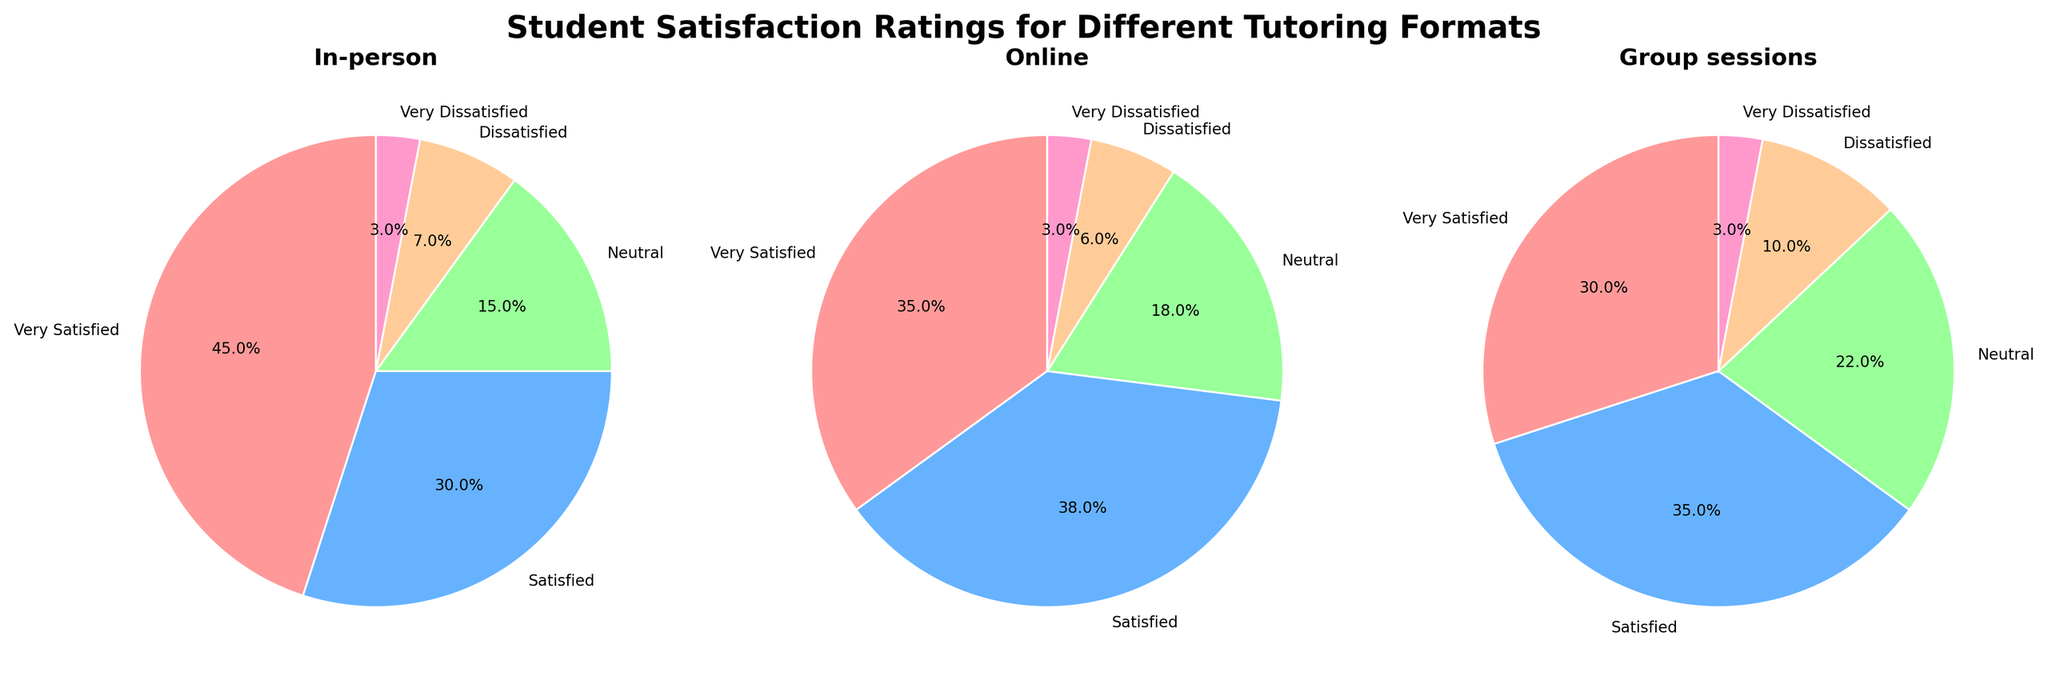What is the title of the figure? The title can be found at the top of the figure and it usually describes what the figure is about.
Answer: Student Satisfaction Ratings for Different Tutoring Formats Which tutoring format has the highest percentage of 'Very Satisfied' students? By looking at the largest segment labeled 'Very Satisfied' and comparing the percentages among the three pie charts.
Answer: In-person What is the combined percentage of 'Dissatisfied' and 'Very Dissatisfied' students in the Online format? Add the percentages of the 'Dissatisfied' and 'Very Dissatisfied' sections in the Online pie chart (6% and 3%).
Answer: 9% How does the percentage of 'Neutral' students in Group sessions compare to that in the In-person format? Compare the 'Neutral' section in both Group sessions and In-person pie charts (22% vs 15%).
Answer: Group sessions is higher by 7% Which tutoring format has the smallest proportion of 'Satisfied' students? Compare the 'Satisfied' sections across all three pie charts (30%, 38%, and 35%).
Answer: In-person What's the total percentage of students who are at least 'Satisfied' with the In-person format? Add the percentages of 'Very Satisfied' and 'Satisfied' sections in the In-person pie chart (45% and 30%).
Answer: 75% In which tutoring format are students least likely to be 'Dissatisfied'? Look for the smallest 'Dissatisfied' section among the three pie charts (7%, 6%, and 10%).
Answer: Online Rank the formats from highest to lowest based on the percentage of 'Very Dissatisfied' students. Compare the 'Very Dissatisfied' sections in all three pie charts (3% across the board).
Answer: In-person = Online = Group sessions What is the most common rating among students in Online tutoring format? Look for the largest section in the Online pie chart.
Answer: Satisfied Which format has the greatest percentage difference between 'Very Satisfied' and 'Neutral' students? Calculate the differences for each pie chart: In-person (45% - 15%), Online (35% - 18%), Group sessions (30% - 22%).
Answer: In-person 